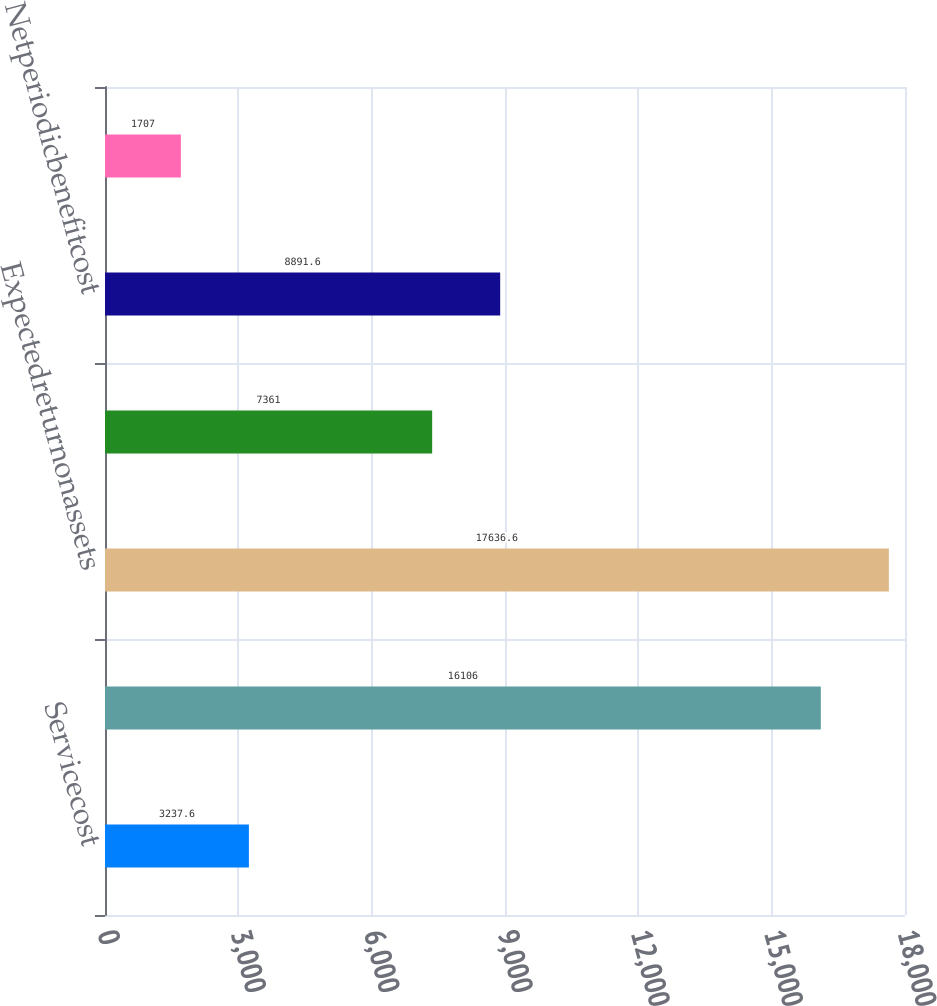Convert chart. <chart><loc_0><loc_0><loc_500><loc_500><bar_chart><fcel>Servicecost<fcel>Interestcost<fcel>Expectedreturnonassets<fcel>Amortizationofactuarialloss<fcel>Netperiodicbenefitcost<fcel>Netperiodicbenefitcost(income)<nl><fcel>3237.6<fcel>16106<fcel>17636.6<fcel>7361<fcel>8891.6<fcel>1707<nl></chart> 